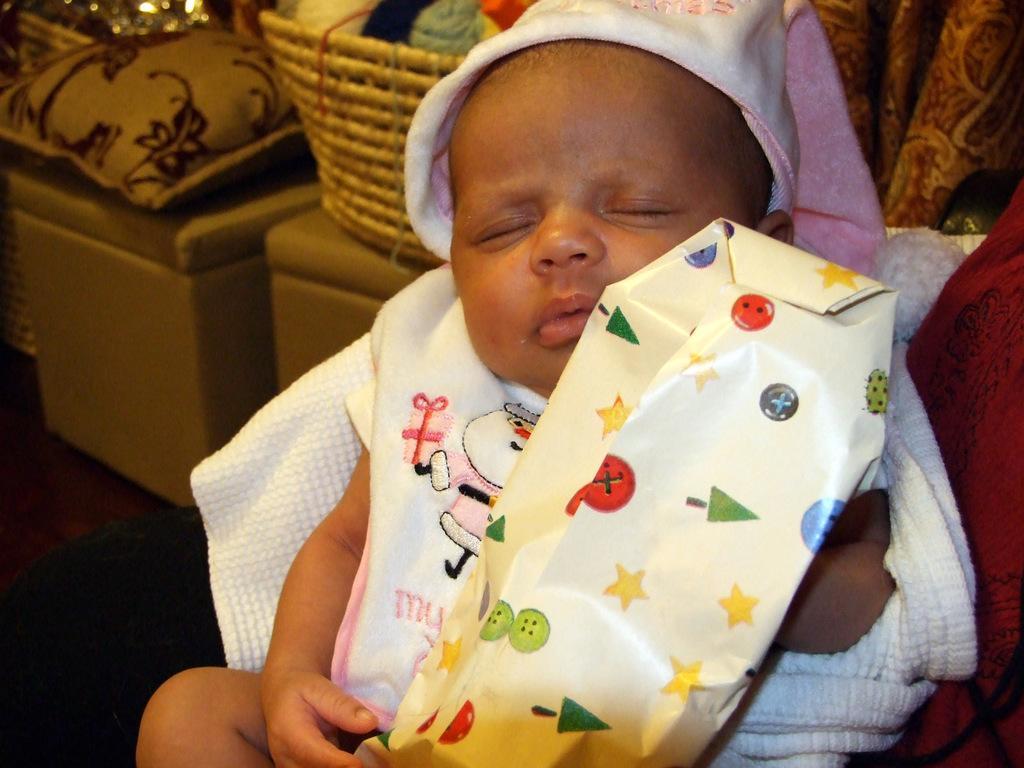Please provide a concise description of this image. In the picture I can see a baby sleeping and holding an object in his hands and there are some other objects in the background. 